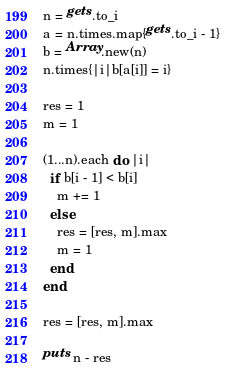Convert code to text. <code><loc_0><loc_0><loc_500><loc_500><_Ruby_>n = gets.to_i
a = n.times.map{gets.to_i - 1}
b = Array.new(n)
n.times{|i|b[a[i]] = i}

res = 1
m = 1

(1...n).each do |i|
  if b[i - 1] < b[i]
    m += 1
  else
    res = [res, m].max
    m = 1
  end
end

res = [res, m].max

puts n - res</code> 